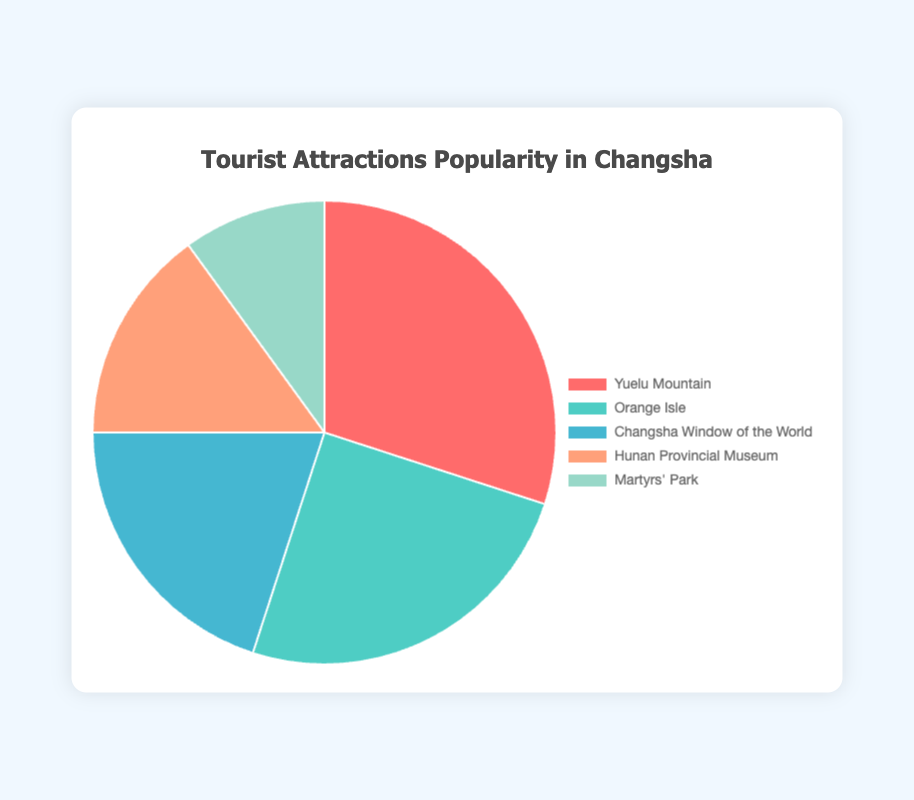What is the most popular tourist attraction in Changsha? The chart shows different tourist attractions with their corresponding popularity percentages. The highest percentage is 30%, which corresponds to Yuelu Mountain.
Answer: Yuelu Mountain Which tourist spot has the second-highest popularity percentage? By looking at the chart, the second-largest segment represents 25% of the popularity. This corresponds to Orange Isle.
Answer: Orange Isle What is the combined popularity percentage of Orange Isle and Hunan Provincial Museum? The chart indicates Orange Isle has a popularity of 25% and Hunan Provincial Museum has 15%. By adding these percentages together, the combined popularity is 25% + 15% = 40%.
Answer: 40% How much less popular is Martyrs' Park compared to Yuelu Mountain? Martyrs' Park has a popularity of 10%, while Yuelu Mountain has 30%. The difference is 30% - 10% = 20%.
Answer: 20% Which attraction is half as popular as Yuelu Mountain? Yuelu Mountain has 30% popularity. Half of 30% is 15%, which corresponds to Hunan Provincial Museum.
Answer: Hunan Provincial Museum Are any two attractions equally popular? By examining the chart, it's clear that each attraction has a unique popularity percentage, with no two attractions having the same percentage.
Answer: No What is the average popularity percentage of all top 5 attractions? Sum the popularity percentages: 30% + 25% + 20% + 15% + 10% = 100%. Divide by the number of attractions (5). Average = 100% / 5 = 20%.
Answer: 20% Which colors are used to represent the Changsha Window of the World and Martyrs' Park? The Changsha Window of the World is represented by a blue segment and Martyrs' Park by a green segment in the chart.
Answer: Blue and green How does the popularity of Changsha Window of the World compare to Orange Isle? The chart shows Changsha Window of the World with 20% and Orange Isle with 25%. Thus, Orange Isle is more popular by 5%.
Answer: Orange Isle is more popular by 5% What is the total popularity percentage of attractions with less than 20% popularity? The attractions with less than 20% popularity are Hunan Provincial Museum (15%) and Martyrs' Park (10%). Their total is 15% + 10% = 25%.
Answer: 25% 